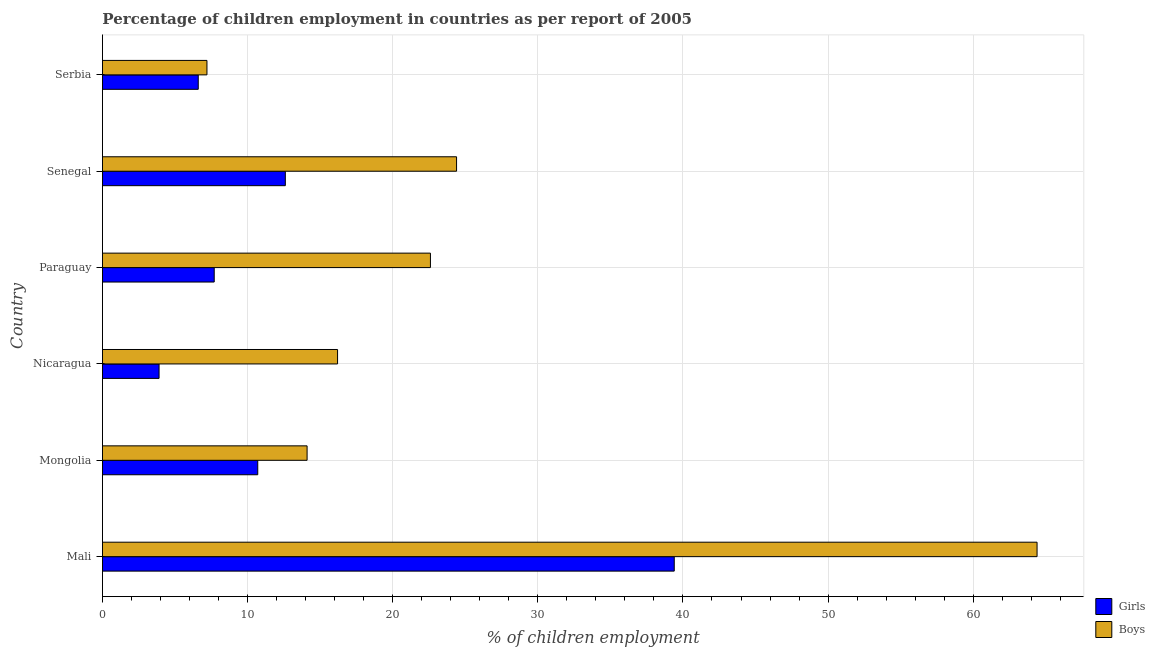How many different coloured bars are there?
Make the answer very short. 2. Are the number of bars per tick equal to the number of legend labels?
Give a very brief answer. Yes. Are the number of bars on each tick of the Y-axis equal?
Give a very brief answer. Yes. What is the label of the 2nd group of bars from the top?
Keep it short and to the point. Senegal. In how many cases, is the number of bars for a given country not equal to the number of legend labels?
Provide a succinct answer. 0. Across all countries, what is the maximum percentage of employed boys?
Offer a very short reply. 64.4. Across all countries, what is the minimum percentage of employed boys?
Provide a short and direct response. 7.2. In which country was the percentage of employed girls maximum?
Ensure brevity in your answer.  Mali. In which country was the percentage of employed girls minimum?
Offer a terse response. Nicaragua. What is the total percentage of employed boys in the graph?
Give a very brief answer. 148.9. What is the difference between the percentage of employed boys in Mongolia and the percentage of employed girls in Paraguay?
Ensure brevity in your answer.  6.4. What is the average percentage of employed girls per country?
Your answer should be very brief. 13.48. What is the difference between the percentage of employed boys and percentage of employed girls in Mali?
Offer a very short reply. 25. In how many countries, is the percentage of employed boys greater than 18 %?
Your answer should be very brief. 3. What is the ratio of the percentage of employed girls in Nicaragua to that in Serbia?
Your response must be concise. 0.59. Is the percentage of employed girls in Mali less than that in Paraguay?
Keep it short and to the point. No. Is the difference between the percentage of employed boys in Paraguay and Serbia greater than the difference between the percentage of employed girls in Paraguay and Serbia?
Provide a short and direct response. Yes. What is the difference between the highest and the second highest percentage of employed girls?
Your response must be concise. 26.8. What is the difference between the highest and the lowest percentage of employed girls?
Your answer should be compact. 35.5. In how many countries, is the percentage of employed girls greater than the average percentage of employed girls taken over all countries?
Your answer should be very brief. 1. What does the 2nd bar from the top in Mongolia represents?
Ensure brevity in your answer.  Girls. What does the 1st bar from the bottom in Mali represents?
Your response must be concise. Girls. How many bars are there?
Provide a short and direct response. 12. Are the values on the major ticks of X-axis written in scientific E-notation?
Your response must be concise. No. Does the graph contain grids?
Your answer should be compact. Yes. Where does the legend appear in the graph?
Your response must be concise. Bottom right. How many legend labels are there?
Offer a terse response. 2. What is the title of the graph?
Your answer should be compact. Percentage of children employment in countries as per report of 2005. Does "Arms exports" appear as one of the legend labels in the graph?
Give a very brief answer. No. What is the label or title of the X-axis?
Provide a short and direct response. % of children employment. What is the label or title of the Y-axis?
Make the answer very short. Country. What is the % of children employment of Girls in Mali?
Ensure brevity in your answer.  39.4. What is the % of children employment in Boys in Mali?
Make the answer very short. 64.4. What is the % of children employment in Girls in Mongolia?
Make the answer very short. 10.7. What is the % of children employment in Boys in Mongolia?
Provide a succinct answer. 14.1. What is the % of children employment of Girls in Nicaragua?
Provide a short and direct response. 3.9. What is the % of children employment of Boys in Paraguay?
Make the answer very short. 22.6. What is the % of children employment of Girls in Senegal?
Provide a short and direct response. 12.6. What is the % of children employment in Boys in Senegal?
Your response must be concise. 24.4. Across all countries, what is the maximum % of children employment in Girls?
Give a very brief answer. 39.4. Across all countries, what is the maximum % of children employment in Boys?
Give a very brief answer. 64.4. Across all countries, what is the minimum % of children employment of Boys?
Offer a terse response. 7.2. What is the total % of children employment in Girls in the graph?
Give a very brief answer. 80.9. What is the total % of children employment in Boys in the graph?
Ensure brevity in your answer.  148.9. What is the difference between the % of children employment in Girls in Mali and that in Mongolia?
Ensure brevity in your answer.  28.7. What is the difference between the % of children employment in Boys in Mali and that in Mongolia?
Your response must be concise. 50.3. What is the difference between the % of children employment in Girls in Mali and that in Nicaragua?
Your answer should be compact. 35.5. What is the difference between the % of children employment in Boys in Mali and that in Nicaragua?
Keep it short and to the point. 48.2. What is the difference between the % of children employment of Girls in Mali and that in Paraguay?
Ensure brevity in your answer.  31.7. What is the difference between the % of children employment in Boys in Mali and that in Paraguay?
Your answer should be compact. 41.8. What is the difference between the % of children employment in Girls in Mali and that in Senegal?
Your response must be concise. 26.8. What is the difference between the % of children employment in Girls in Mali and that in Serbia?
Ensure brevity in your answer.  32.8. What is the difference between the % of children employment in Boys in Mali and that in Serbia?
Provide a succinct answer. 57.2. What is the difference between the % of children employment in Boys in Mongolia and that in Nicaragua?
Provide a succinct answer. -2.1. What is the difference between the % of children employment of Boys in Mongolia and that in Paraguay?
Keep it short and to the point. -8.5. What is the difference between the % of children employment in Girls in Mongolia and that in Senegal?
Make the answer very short. -1.9. What is the difference between the % of children employment of Girls in Mongolia and that in Serbia?
Provide a short and direct response. 4.1. What is the difference between the % of children employment in Boys in Mongolia and that in Serbia?
Offer a terse response. 6.9. What is the difference between the % of children employment in Girls in Nicaragua and that in Paraguay?
Your answer should be compact. -3.8. What is the difference between the % of children employment in Boys in Nicaragua and that in Serbia?
Your response must be concise. 9. What is the difference between the % of children employment in Girls in Paraguay and that in Senegal?
Offer a very short reply. -4.9. What is the difference between the % of children employment in Boys in Paraguay and that in Senegal?
Your response must be concise. -1.8. What is the difference between the % of children employment in Girls in Mali and the % of children employment in Boys in Mongolia?
Provide a short and direct response. 25.3. What is the difference between the % of children employment in Girls in Mali and the % of children employment in Boys in Nicaragua?
Your response must be concise. 23.2. What is the difference between the % of children employment in Girls in Mali and the % of children employment in Boys in Senegal?
Your answer should be very brief. 15. What is the difference between the % of children employment of Girls in Mali and the % of children employment of Boys in Serbia?
Your response must be concise. 32.2. What is the difference between the % of children employment of Girls in Mongolia and the % of children employment of Boys in Nicaragua?
Your response must be concise. -5.5. What is the difference between the % of children employment of Girls in Mongolia and the % of children employment of Boys in Paraguay?
Make the answer very short. -11.9. What is the difference between the % of children employment in Girls in Mongolia and the % of children employment in Boys in Senegal?
Your answer should be very brief. -13.7. What is the difference between the % of children employment in Girls in Nicaragua and the % of children employment in Boys in Paraguay?
Your answer should be very brief. -18.7. What is the difference between the % of children employment in Girls in Nicaragua and the % of children employment in Boys in Senegal?
Provide a succinct answer. -20.5. What is the difference between the % of children employment in Girls in Nicaragua and the % of children employment in Boys in Serbia?
Give a very brief answer. -3.3. What is the difference between the % of children employment in Girls in Paraguay and the % of children employment in Boys in Senegal?
Offer a terse response. -16.7. What is the average % of children employment in Girls per country?
Your response must be concise. 13.48. What is the average % of children employment in Boys per country?
Keep it short and to the point. 24.82. What is the difference between the % of children employment in Girls and % of children employment in Boys in Mali?
Offer a very short reply. -25. What is the difference between the % of children employment of Girls and % of children employment of Boys in Paraguay?
Your response must be concise. -14.9. What is the ratio of the % of children employment in Girls in Mali to that in Mongolia?
Keep it short and to the point. 3.68. What is the ratio of the % of children employment in Boys in Mali to that in Mongolia?
Keep it short and to the point. 4.57. What is the ratio of the % of children employment in Girls in Mali to that in Nicaragua?
Keep it short and to the point. 10.1. What is the ratio of the % of children employment in Boys in Mali to that in Nicaragua?
Make the answer very short. 3.98. What is the ratio of the % of children employment in Girls in Mali to that in Paraguay?
Your answer should be very brief. 5.12. What is the ratio of the % of children employment of Boys in Mali to that in Paraguay?
Offer a terse response. 2.85. What is the ratio of the % of children employment in Girls in Mali to that in Senegal?
Your answer should be compact. 3.13. What is the ratio of the % of children employment of Boys in Mali to that in Senegal?
Provide a succinct answer. 2.64. What is the ratio of the % of children employment of Girls in Mali to that in Serbia?
Provide a short and direct response. 5.97. What is the ratio of the % of children employment of Boys in Mali to that in Serbia?
Offer a terse response. 8.94. What is the ratio of the % of children employment in Girls in Mongolia to that in Nicaragua?
Offer a terse response. 2.74. What is the ratio of the % of children employment of Boys in Mongolia to that in Nicaragua?
Provide a succinct answer. 0.87. What is the ratio of the % of children employment of Girls in Mongolia to that in Paraguay?
Offer a very short reply. 1.39. What is the ratio of the % of children employment in Boys in Mongolia to that in Paraguay?
Offer a very short reply. 0.62. What is the ratio of the % of children employment of Girls in Mongolia to that in Senegal?
Your answer should be compact. 0.85. What is the ratio of the % of children employment in Boys in Mongolia to that in Senegal?
Provide a short and direct response. 0.58. What is the ratio of the % of children employment in Girls in Mongolia to that in Serbia?
Give a very brief answer. 1.62. What is the ratio of the % of children employment of Boys in Mongolia to that in Serbia?
Offer a very short reply. 1.96. What is the ratio of the % of children employment of Girls in Nicaragua to that in Paraguay?
Give a very brief answer. 0.51. What is the ratio of the % of children employment in Boys in Nicaragua to that in Paraguay?
Provide a succinct answer. 0.72. What is the ratio of the % of children employment of Girls in Nicaragua to that in Senegal?
Provide a succinct answer. 0.31. What is the ratio of the % of children employment of Boys in Nicaragua to that in Senegal?
Ensure brevity in your answer.  0.66. What is the ratio of the % of children employment of Girls in Nicaragua to that in Serbia?
Provide a short and direct response. 0.59. What is the ratio of the % of children employment of Boys in Nicaragua to that in Serbia?
Make the answer very short. 2.25. What is the ratio of the % of children employment in Girls in Paraguay to that in Senegal?
Provide a succinct answer. 0.61. What is the ratio of the % of children employment in Boys in Paraguay to that in Senegal?
Provide a succinct answer. 0.93. What is the ratio of the % of children employment in Boys in Paraguay to that in Serbia?
Give a very brief answer. 3.14. What is the ratio of the % of children employment of Girls in Senegal to that in Serbia?
Provide a short and direct response. 1.91. What is the ratio of the % of children employment of Boys in Senegal to that in Serbia?
Give a very brief answer. 3.39. What is the difference between the highest and the second highest % of children employment of Girls?
Your answer should be very brief. 26.8. What is the difference between the highest and the lowest % of children employment in Girls?
Provide a succinct answer. 35.5. What is the difference between the highest and the lowest % of children employment of Boys?
Your response must be concise. 57.2. 